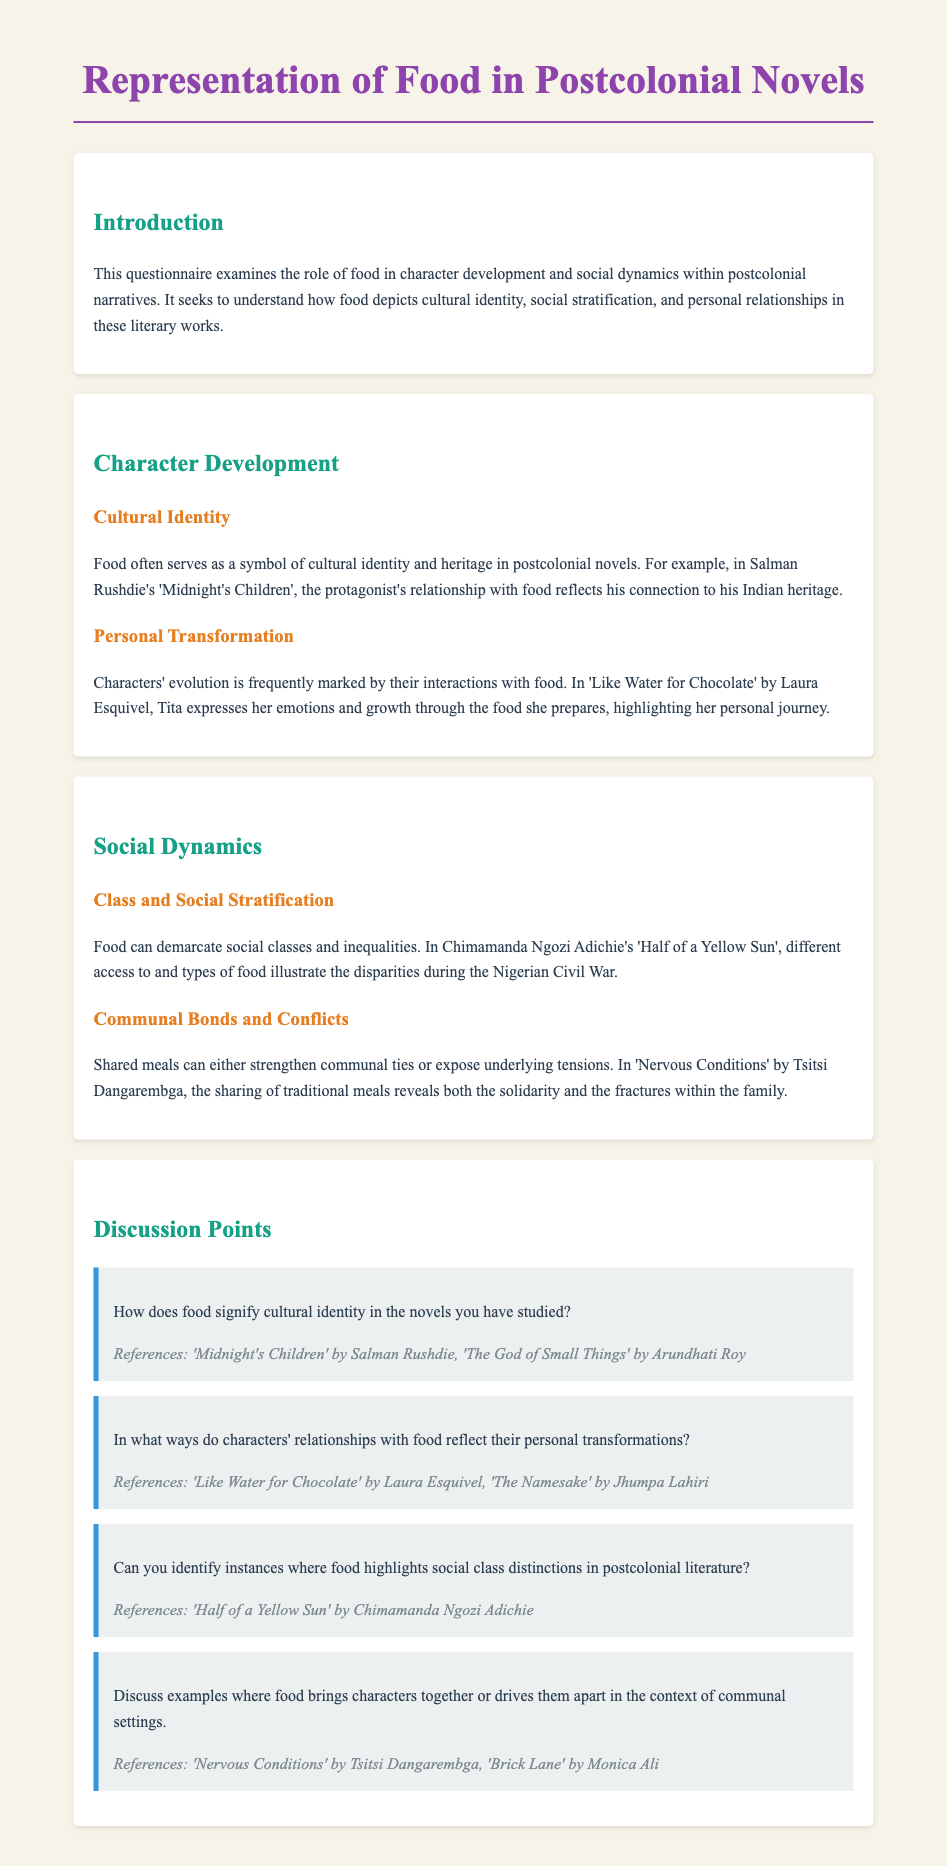What is the title of the questionnaire? The title is stated at the top of the document as "Representation of Food in Postcolonial Novels."
Answer: Representation of Food in Postcolonial Novels Who is the author of 'Midnight's Children'? 'Midnight's Children' is authored by Salman Rushdie as mentioned in the discussion on cultural identity.
Answer: Salman Rushdie What is a key theme in 'Like Water for Chocolate'? The document points out that a key theme in 'Like Water for Chocolate' is Tita expressing her emotions through food.
Answer: Emotions through food Which social issue is highlighted in 'Half of a Yellow Sun'? The novel illustrates disparities during the Nigerian Civil War, connecting food to social issues.
Answer: Disparities during the Nigerian Civil War Which character is associated with food as a means of personal transformation in 'The Namesake'? The 'The Namesake' is referenced in connection with personal transformation through food but does not specify a character's name.
Answer: Not specified How does food affect communal bonds in 'Nervous Conditions'? Sharing traditional meals in 'Nervous Conditions' reveals solidarity and fractures within the family, affecting communal bonds.
Answer: Solidarity and fractures What topic is discussed in the introduction of the questionnaire? The introduction outlines that the questionnaire examines the role of food in character development and social dynamics.
Answer: Role of food in character development and social dynamics What type of meals are discussed in relation to social stratification? The document discusses different access to and types of food as indicators of social class distinctions.
Answer: Different access to food 